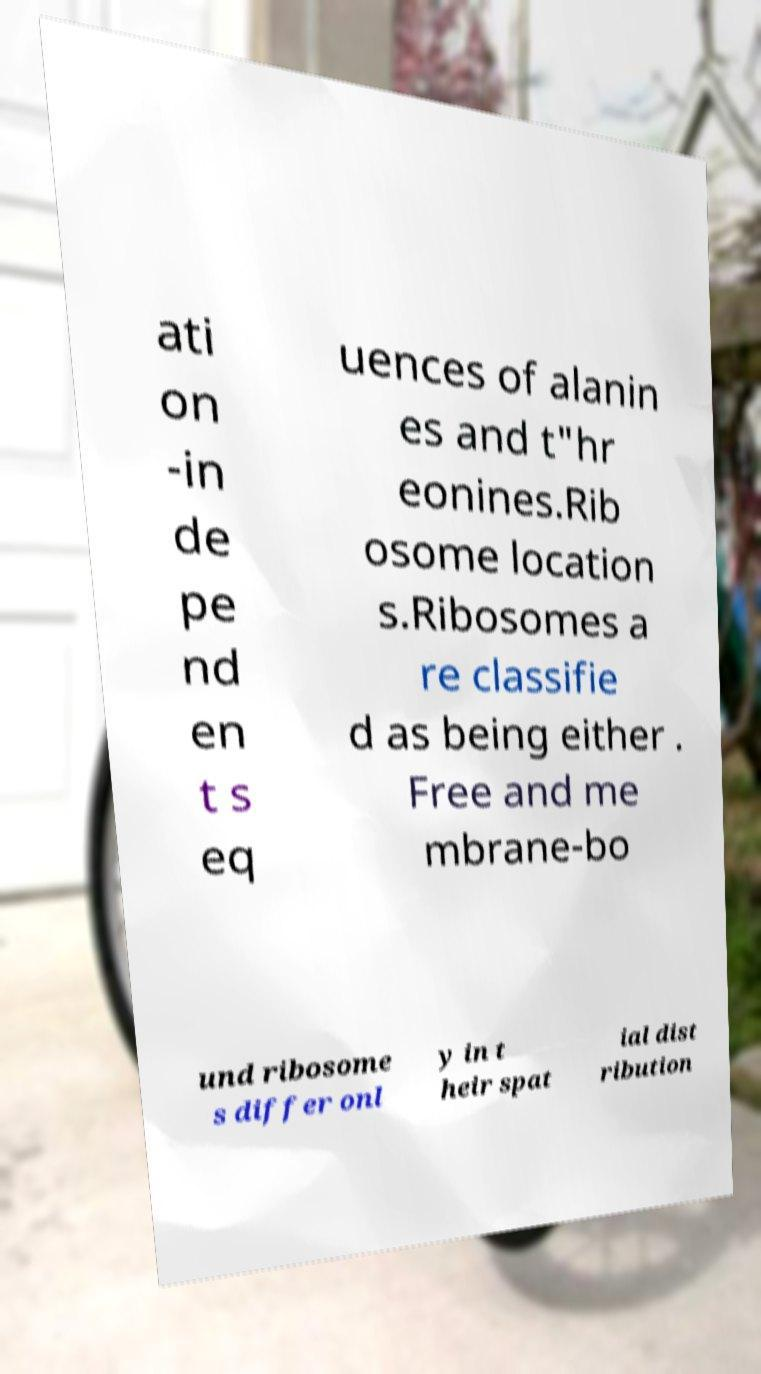What messages or text are displayed in this image? I need them in a readable, typed format. ati on -in de pe nd en t s eq uences of alanin es and t"hr eonines.Rib osome location s.Ribosomes a re classifie d as being either . Free and me mbrane-bo und ribosome s differ onl y in t heir spat ial dist ribution 